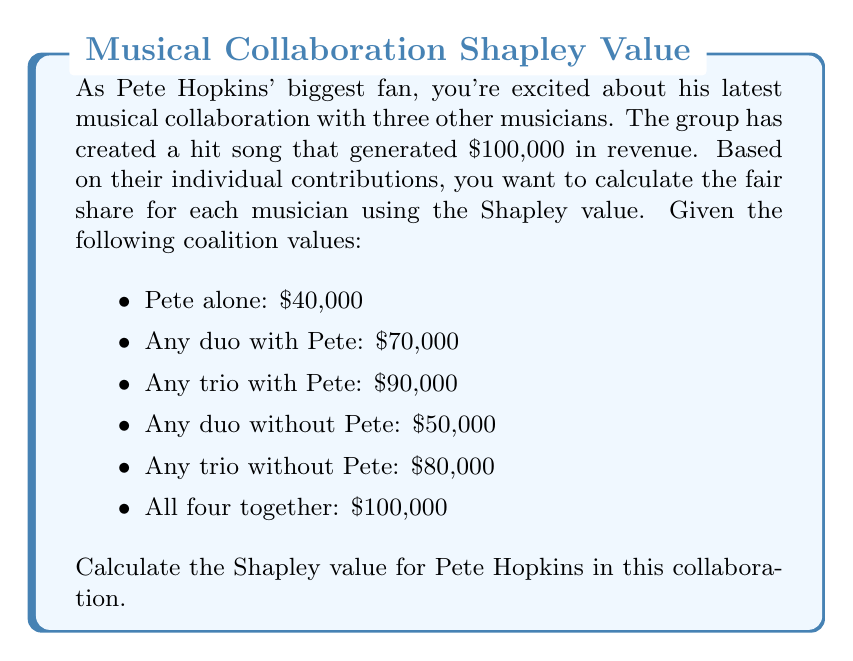Show me your answer to this math problem. To calculate the Shapley value for Pete Hopkins, we need to consider all possible permutations of the players joining the coalition and determine Pete's marginal contribution in each case. There are 4! = 24 possible permutations.

Let's denote Pete as P and the other musicians as A, B, and C.

1. Calculate Pete's marginal contribution in each permutation:

- P,A,B,C: $40,000
- P,A,C,B: $40,000
- P,B,A,C: $40,000
- P,B,C,A: $40,000
- P,C,A,B: $40,000
- P,C,B,A: $40,000
- A,P,B,C: $70,000 - $0 = $70,000
- A,P,C,B: $70,000 - $0 = $70,000
- B,P,A,C: $70,000 - $0 = $70,000
- B,P,C,A: $70,000 - $0 = $70,000
- C,P,A,B: $70,000 - $0 = $70,000
- C,P,B,A: $70,000 - $0 = $70,000
- A,B,P,C: $90,000 - $50,000 = $40,000
- A,C,P,B: $90,000 - $50,000 = $40,000
- B,A,P,C: $90,000 - $50,000 = $40,000
- B,C,P,A: $90,000 - $50,000 = $40,000
- C,A,P,B: $90,000 - $50,000 = $40,000
- C,B,P,A: $90,000 - $50,000 = $40,000
- A,B,C,P: $100,000 - $80,000 = $20,000
- A,C,B,P: $100,000 - $80,000 = $20,000
- B,A,C,P: $100,000 - $80,000 = $20,000
- B,C,A,P: $100,000 - $80,000 = $20,000
- C,A,B,P: $100,000 - $80,000 = $20,000
- C,B,A,P: $100,000 - $80,000 = $20,000

2. Sum up all the marginal contributions:

$$(6 \times 40,000) + (6 \times 70,000) + (6 \times 40,000) + (6 \times 20,000) = 1,020,000$$

3. Calculate the average by dividing the sum by the number of permutations:

$$\text{Shapley Value} = \frac{1,020,000}{24} = 42,500$$

Therefore, the Shapley value for Pete Hopkins in this collaboration is $42,500.
Answer: $42,500 